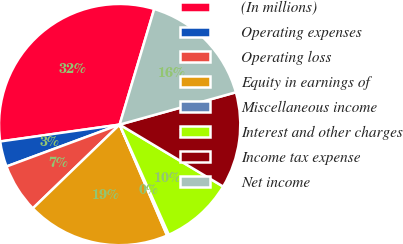<chart> <loc_0><loc_0><loc_500><loc_500><pie_chart><fcel>(In millions)<fcel>Operating expenses<fcel>Operating loss<fcel>Equity in earnings of<fcel>Miscellaneous income<fcel>Interest and other charges<fcel>Income tax expense<fcel>Net income<nl><fcel>31.86%<fcel>3.41%<fcel>6.57%<fcel>19.22%<fcel>0.25%<fcel>9.73%<fcel>12.9%<fcel>16.06%<nl></chart> 